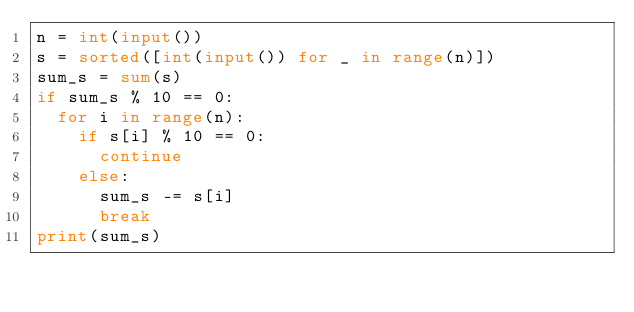<code> <loc_0><loc_0><loc_500><loc_500><_Python_>n = int(input())
s = sorted([int(input()) for _ in range(n)])
sum_s = sum(s)
if sum_s % 10 == 0:
  for i in range(n):
    if s[i] % 10 == 0:
      continue
    else:
      sum_s -= s[i]
      break
print(sum_s)</code> 